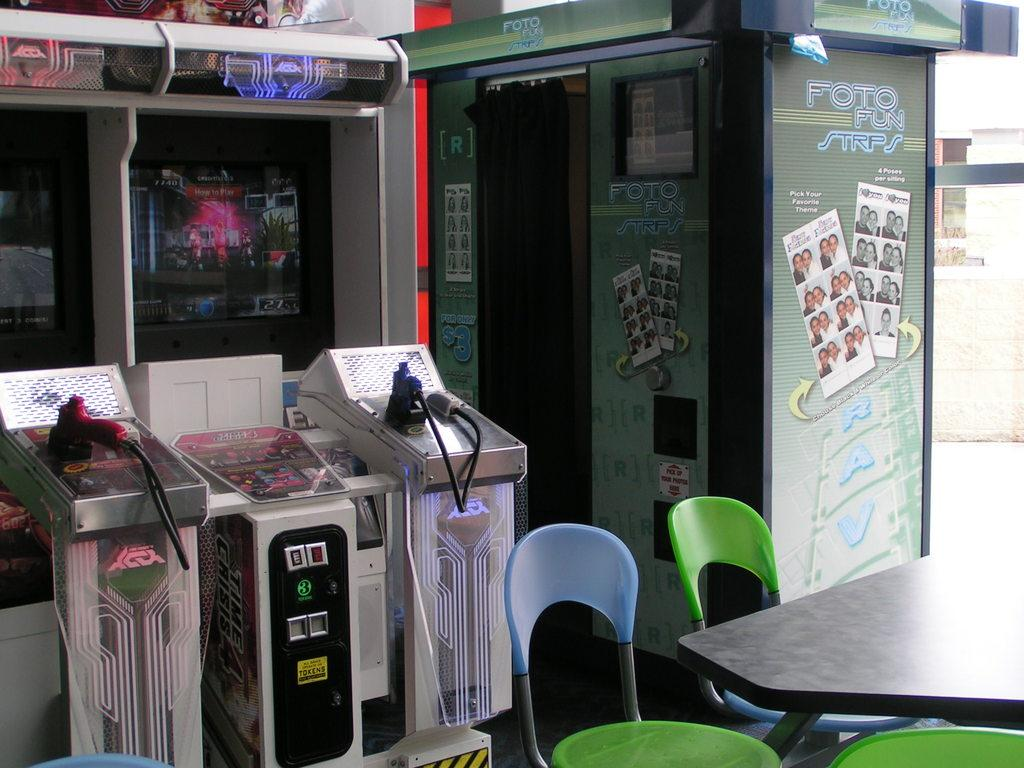What type of furniture is located on the right side of the image? There are chairs and a table on the right side of the image. What can be seen in the background of the image? Electronic devices and big posters on platforms are visible in the background of the image. Are there any other objects present in the background of the image? Yes, there are other objects visible in the background of the image. What news is being reported on the doll in the image? There is no doll present in the image, and therefore no news can be reported on it. What type of peace is being promoted by the electronic devices in the image? The electronic devices in the image are not promoting any type of peace; they are simply visible in the background. 